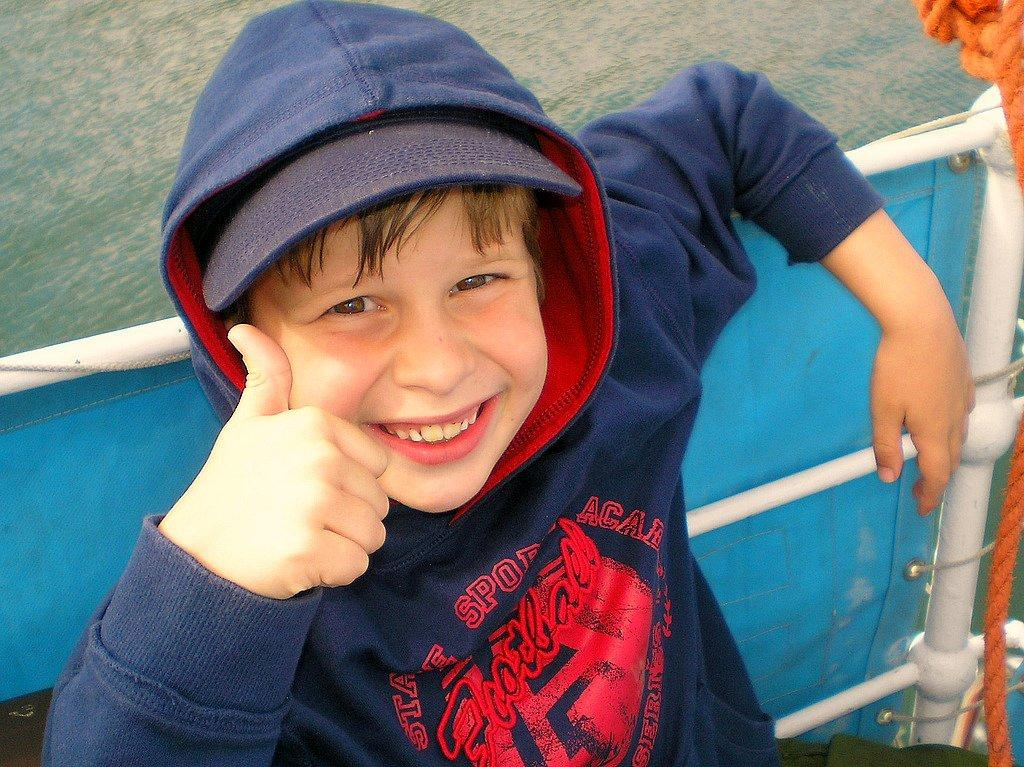Who is present in the image? There is a boy in the image. What is the boy's expression? The boy is smiling. What can be seen in the background of the image? There is a fence in the image. What natural element is visible in the image? There is water visible in the image. What type of office furniture can be seen in the image? There is no office furniture present in the image; it features a boy smiling with a fence and water visible in the background. 